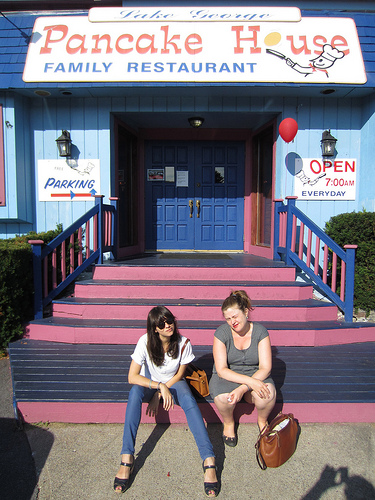<image>
Is the shoe strap in front of the sign? Yes. The shoe strap is positioned in front of the sign, appearing closer to the camera viewpoint. Where is the door in relation to the lamp? Is it to the left of the lamp? Yes. From this viewpoint, the door is positioned to the left side relative to the lamp. 